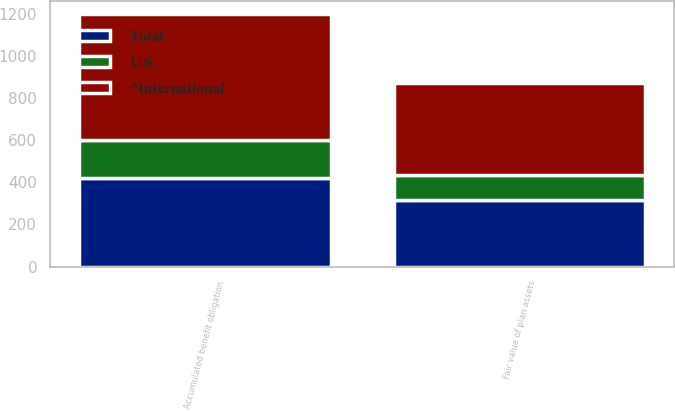<chart> <loc_0><loc_0><loc_500><loc_500><stacked_bar_chart><ecel><fcel>Accumulated benefit obligation<fcel>Fair value of plan assets<nl><fcel>U.S.<fcel>182.1<fcel>119.9<nl><fcel>Total<fcel>418<fcel>315.4<nl><fcel>^International<fcel>600.1<fcel>435.3<nl></chart> 